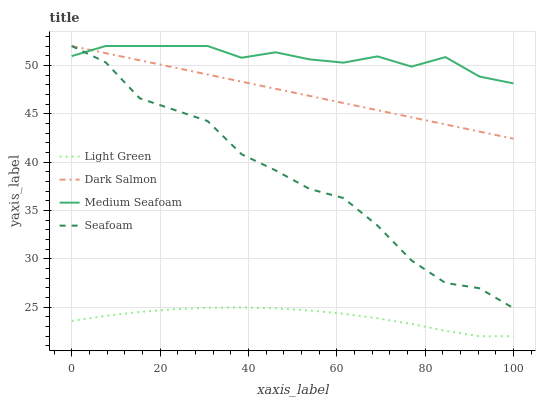Does Light Green have the minimum area under the curve?
Answer yes or no. Yes. Does Medium Seafoam have the maximum area under the curve?
Answer yes or no. Yes. Does Dark Salmon have the minimum area under the curve?
Answer yes or no. No. Does Dark Salmon have the maximum area under the curve?
Answer yes or no. No. Is Dark Salmon the smoothest?
Answer yes or no. Yes. Is Seafoam the roughest?
Answer yes or no. Yes. Is Light Green the smoothest?
Answer yes or no. No. Is Light Green the roughest?
Answer yes or no. No. Does Light Green have the lowest value?
Answer yes or no. Yes. Does Dark Salmon have the lowest value?
Answer yes or no. No. Does Medium Seafoam have the highest value?
Answer yes or no. Yes. Does Light Green have the highest value?
Answer yes or no. No. Is Light Green less than Seafoam?
Answer yes or no. Yes. Is Seafoam greater than Light Green?
Answer yes or no. Yes. Does Seafoam intersect Dark Salmon?
Answer yes or no. Yes. Is Seafoam less than Dark Salmon?
Answer yes or no. No. Is Seafoam greater than Dark Salmon?
Answer yes or no. No. Does Light Green intersect Seafoam?
Answer yes or no. No. 